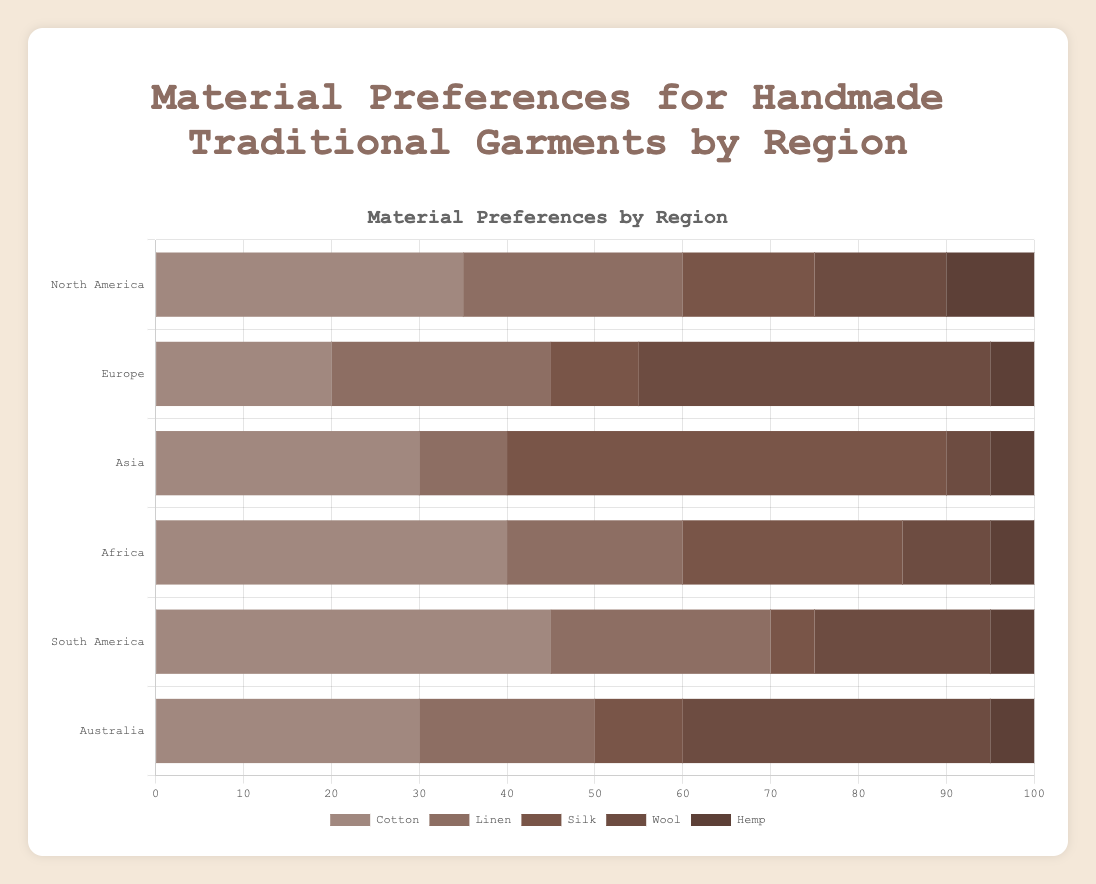Which region shows the highest preference for silk? Look at the bars representing silk across all regions and find the longest bar.
Answer: Asia In which region does linen have the lowest preference percentage? Compare the height of the linen bars across all regions.
Answer: Asia What is the total percentage preference for all materials in South America? Add the percentages for each material in South America: 45 + 25 + 20 + 5 + 5.
Answer: 100 Which region prefers wool the most? Observe the wool bars and identify the region with the tallest wool bar.
Answer: Europe What is the average preference percentage for cotton across all regions? Add the cotton percentages from all regions and divide by the number of regions: (35 + 20 + 30 + 40 + 45 + 30)/6.
Answer: 33.33 Compare the preference for hemp in North America and Australia. Check the height of the hemp bars for North America and Australia and compare them. Both are the same in height.
Answer: Equal Which material is least preferred in both North America and Europe? Look at the least tall bars in North America and Europe. For North America, it's hemp (10%). For Europe, it's hemp (5%).
Answer: Hemp How much more is the preference percentage for silk in Asia compared to Africa? Subtract the preference percentage for silk in Africa from the percentage for silk in Asia: 50 - 25.
Answer: 25 Which material has the same preference percentage in Asia, Africa, and South America? Check the bars that have the same height in these regions. The hemp bars in these regions all have a preference percentage of 5.
Answer: Hemp Is the percentage preference for wool in Australia higher or lower than in North America? Compare the wool bar height in Australia and North America; the one in Australia is taller.
Answer: Higher 